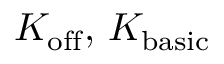<formula> <loc_0><loc_0><loc_500><loc_500>K _ { o f f } , \, K _ { b a s i c }</formula> 